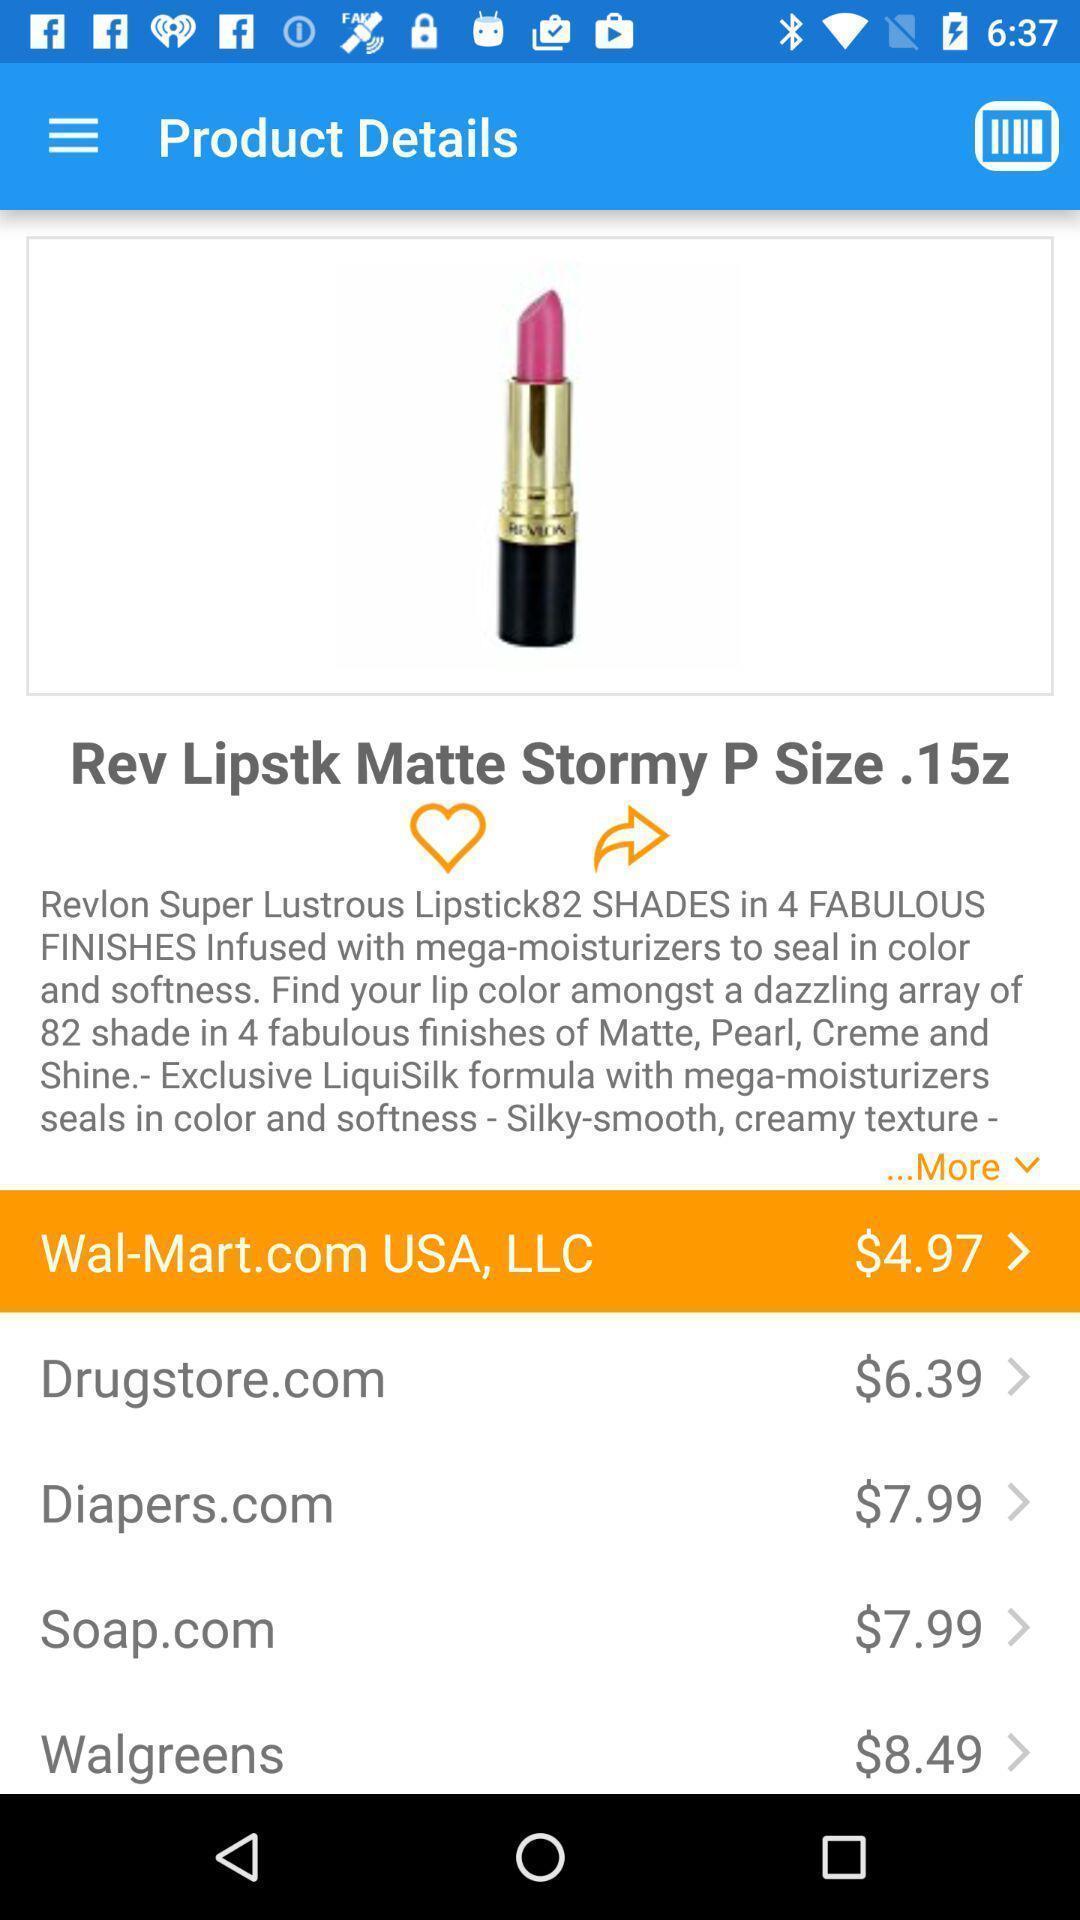What can you discern from this picture? Product details displaying in this page. 